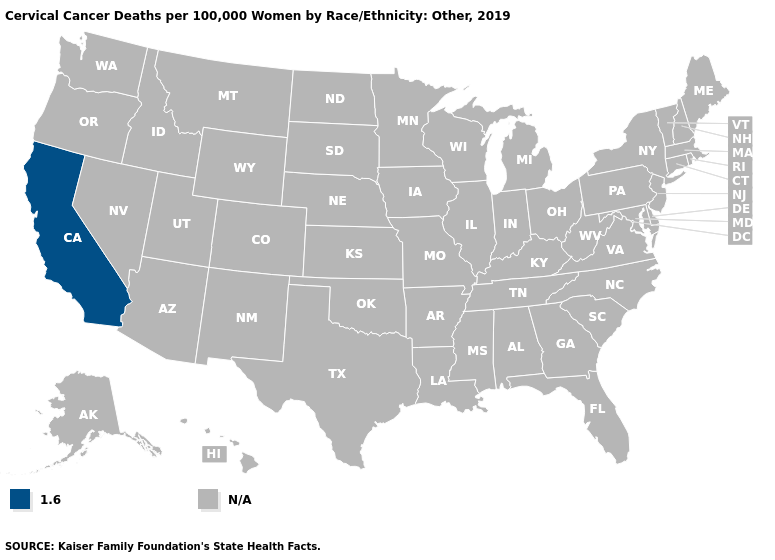What is the value of New Mexico?
Answer briefly. N/A. Name the states that have a value in the range N/A?
Give a very brief answer. Alabama, Alaska, Arizona, Arkansas, Colorado, Connecticut, Delaware, Florida, Georgia, Hawaii, Idaho, Illinois, Indiana, Iowa, Kansas, Kentucky, Louisiana, Maine, Maryland, Massachusetts, Michigan, Minnesota, Mississippi, Missouri, Montana, Nebraska, Nevada, New Hampshire, New Jersey, New Mexico, New York, North Carolina, North Dakota, Ohio, Oklahoma, Oregon, Pennsylvania, Rhode Island, South Carolina, South Dakota, Tennessee, Texas, Utah, Vermont, Virginia, Washington, West Virginia, Wisconsin, Wyoming. Which states have the lowest value in the USA?
Be succinct. California. What is the highest value in the USA?
Answer briefly. 1.6. Name the states that have a value in the range 1.6?
Write a very short answer. California. What is the value of Oregon?
Concise answer only. N/A. Does the map have missing data?
Short answer required. Yes. Name the states that have a value in the range 1.6?
Write a very short answer. California. What is the value of Illinois?
Keep it brief. N/A. 